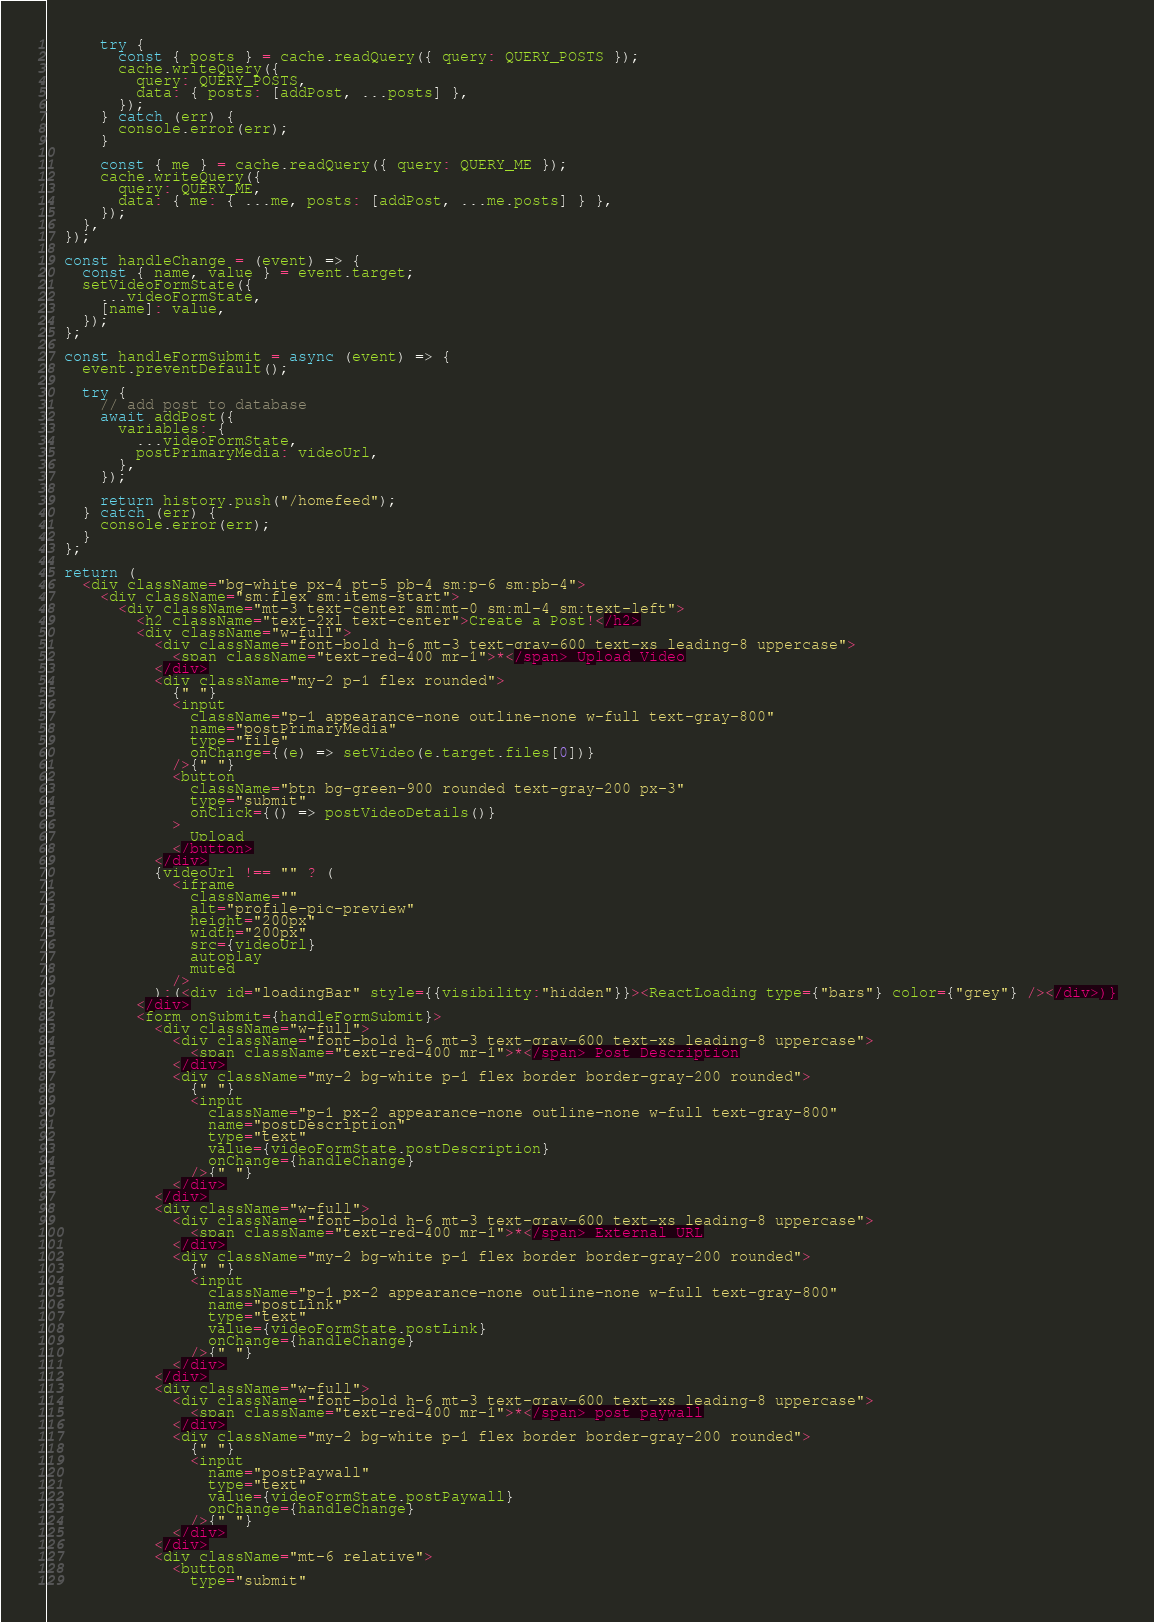Convert code to text. <code><loc_0><loc_0><loc_500><loc_500><_JavaScript_>      try {
        const { posts } = cache.readQuery({ query: QUERY_POSTS });
        cache.writeQuery({
          query: QUERY_POSTS,
          data: { posts: [addPost, ...posts] },
        });
      } catch (err) {
        console.error(err);
      }

      const { me } = cache.readQuery({ query: QUERY_ME });
      cache.writeQuery({
        query: QUERY_ME,
        data: { me: { ...me, posts: [addPost, ...me.posts] } },
      });
    },
  });

  const handleChange = (event) => {
    const { name, value } = event.target;
    setVideoFormState({
      ...videoFormState,
      [name]: value,
    });
  };

  const handleFormSubmit = async (event) => {
    event.preventDefault();

    try {
      // add post to database
      await addPost({
        variables: {
          ...videoFormState,
          postPrimaryMedia: videoUrl,
        },
      });
      
      return history.push("/homefeed");
    } catch (err) {
      console.error(err);
    }
  };

  return (
    <div className="bg-white px-4 pt-5 pb-4 sm:p-6 sm:pb-4">
      <div className="sm:flex sm:items-start">
        <div className="mt-3 text-center sm:mt-0 sm:ml-4 sm:text-left">
          <h2 className="text-2xl text-center">Create a Post!</h2>
          <div className="w-full">
            <div className="font-bold h-6 mt-3 text-gray-600 text-xs leading-8 uppercase">
              <span className="text-red-400 mr-1">*</span> Upload Video
            </div>
            <div className="my-2 p-1 flex rounded">
              {" "}
              <input
                className="p-1 appearance-none outline-none w-full text-gray-800"
                name="postPrimaryMedia"
                type="file"
                onChange={(e) => setVideo(e.target.files[0])}
              />{" "}
              <button
                className="btn bg-green-900 rounded text-gray-200 px-3"
                type="submit"
                onClick={() => postVideoDetails()}
              >
                Upload
              </button>
            </div>
            {videoUrl !== "" ? (
              <iframe
                className=""
                alt="profile-pic-preview"
                height="200px"
                width="200px"
                src={videoUrl}
                autoplay
                muted
              />
            ):(<div id="loadingBar" style={{visibility:"hidden"}}><ReactLoading type={"bars"} color={"grey"} /></div>)}
          </div>
          <form onSubmit={handleFormSubmit}>
            <div className="w-full">
              <div className="font-bold h-6 mt-3 text-gray-600 text-xs leading-8 uppercase">
                <span className="text-red-400 mr-1">*</span> Post Description
              </div>
              <div className="my-2 bg-white p-1 flex border border-gray-200 rounded">
                {" "}
                <input
                  className="p-1 px-2 appearance-none outline-none w-full text-gray-800"
                  name="postDescription"
                  type="text"
                  value={videoFormState.postDescription}
                  onChange={handleChange}
                />{" "}
              </div>
            </div>
            <div className="w-full">
              <div className="font-bold h-6 mt-3 text-gray-600 text-xs leading-8 uppercase">
                <span className="text-red-400 mr-1">*</span> External URL
              </div>
              <div className="my-2 bg-white p-1 flex border border-gray-200 rounded">
                {" "}
                <input
                  className="p-1 px-2 appearance-none outline-none w-full text-gray-800"
                  name="postLink"
                  type="text"
                  value={videoFormState.postLink}
                  onChange={handleChange}
                />{" "}
              </div>
            </div>
            <div className="w-full">
              <div className="font-bold h-6 mt-3 text-gray-600 text-xs leading-8 uppercase">
                <span className="text-red-400 mr-1">*</span> post paywall
              </div>
              <div className="my-2 bg-white p-1 flex border border-gray-200 rounded">
                {" "}
                <input
                  name="postPaywall"
                  type="text"
                  value={videoFormState.postPaywall}
                  onChange={handleChange}
                />{" "}
              </div>
            </div>
            <div className="mt-6 relative">
              <button
                type="submit"</code> 